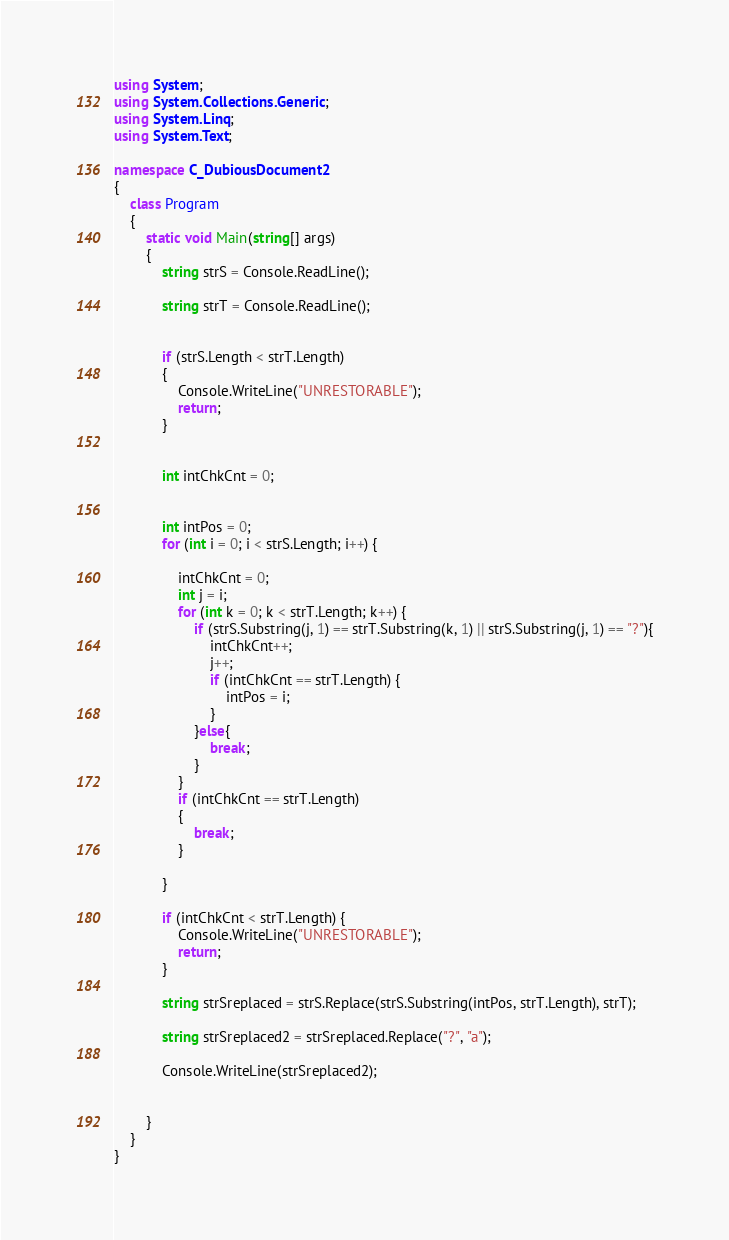Convert code to text. <code><loc_0><loc_0><loc_500><loc_500><_C#_>using System;
using System.Collections.Generic;
using System.Linq;
using System.Text;

namespace C_DubiousDocument2
{
    class Program
    {
        static void Main(string[] args)
        {
            string strS = Console.ReadLine();

            string strT = Console.ReadLine();


            if (strS.Length < strT.Length)
            {
                Console.WriteLine("UNRESTORABLE");
                return;
            }


            int intChkCnt = 0;


            int intPos = 0;
            for (int i = 0; i < strS.Length; i++) {

                intChkCnt = 0;
                int j = i;
                for (int k = 0; k < strT.Length; k++) {
                    if (strS.Substring(j, 1) == strT.Substring(k, 1) || strS.Substring(j, 1) == "?"){
                        intChkCnt++;
                        j++;
                        if (intChkCnt == strT.Length) {
                            intPos = i;
                        }
                    }else{
                        break;
                    }
                }
                if (intChkCnt == strT.Length)
                {
                    break;
                }

            }

            if (intChkCnt < strT.Length) {
                Console.WriteLine("UNRESTORABLE");
                return;
            }

            string strSreplaced = strS.Replace(strS.Substring(intPos, strT.Length), strT);

            string strSreplaced2 = strSreplaced.Replace("?", "a");

            Console.WriteLine(strSreplaced2);


        }
    }
}
</code> 